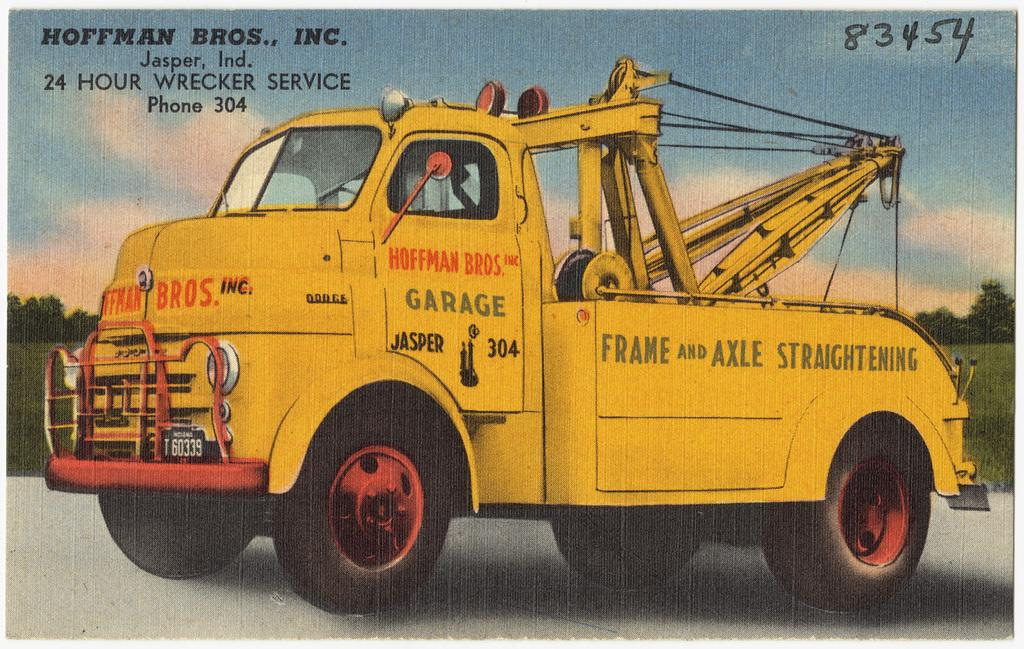What is featured on the poster in the image? The facts do not specify the content of the poster, so we cannot definitively answer this question. What type of vehicle can be seen on the road in the image? The facts do not specify the type of vehicle, so we cannot definitively answer this question. What kind of vegetation is visible in the image? There are trees visible in the image. What is written at the top of the image? There is some text at the top of the image. What type of owl can be seen perched on the vehicle in the image? There is no owl present in the image. What flavor of ice cream is being advertised on the poster in the image? The facts do not specify the content of the poster, so we cannot definitively answer this question. 